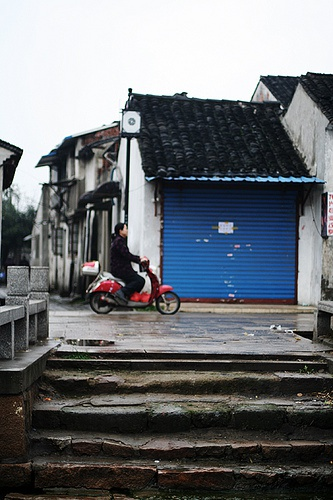Describe the objects in this image and their specific colors. I can see motorcycle in white, black, brown, gray, and maroon tones and people in white, black, gray, brown, and maroon tones in this image. 